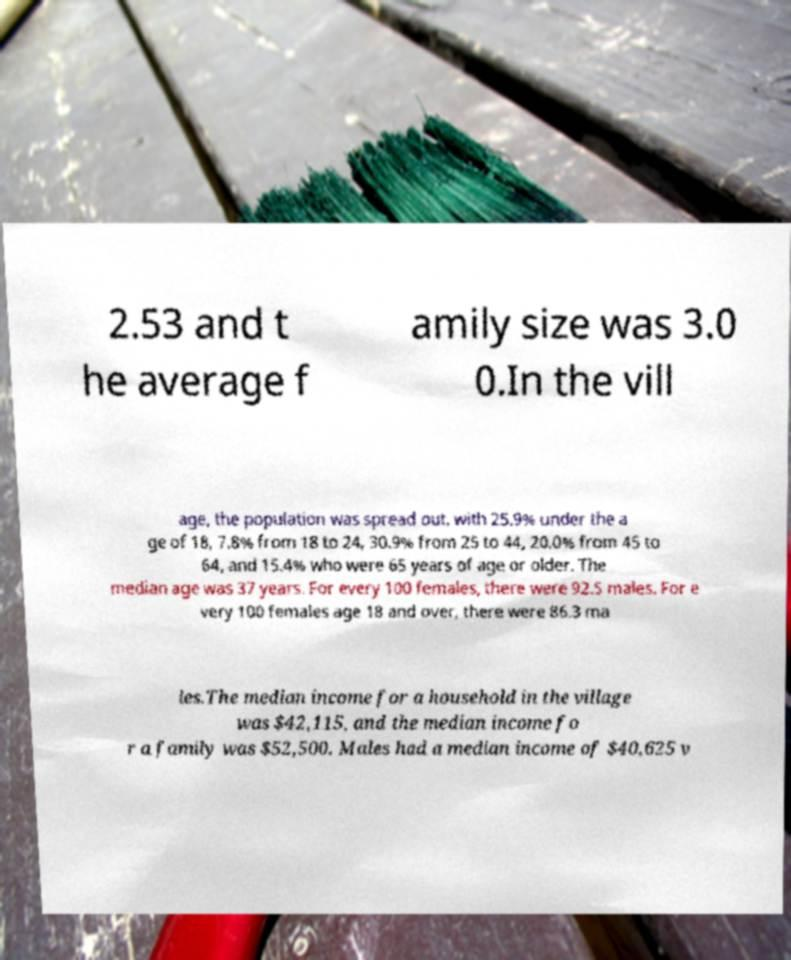I need the written content from this picture converted into text. Can you do that? 2.53 and t he average f amily size was 3.0 0.In the vill age, the population was spread out, with 25.9% under the a ge of 18, 7.8% from 18 to 24, 30.9% from 25 to 44, 20.0% from 45 to 64, and 15.4% who were 65 years of age or older. The median age was 37 years. For every 100 females, there were 92.5 males. For e very 100 females age 18 and over, there were 86.3 ma les.The median income for a household in the village was $42,115, and the median income fo r a family was $52,500. Males had a median income of $40,625 v 